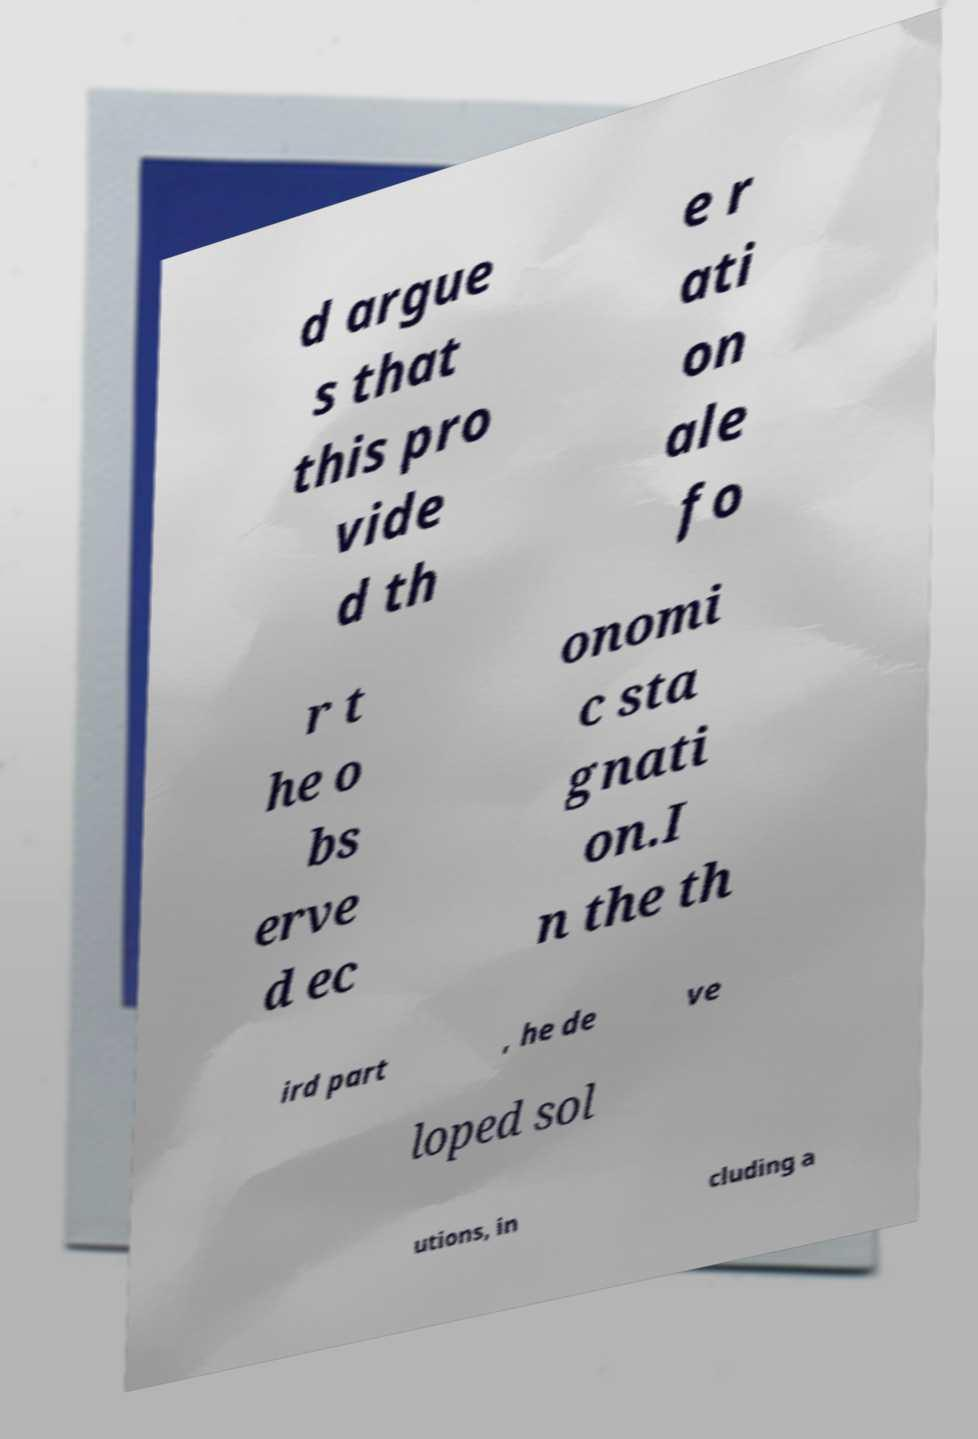I need the written content from this picture converted into text. Can you do that? d argue s that this pro vide d th e r ati on ale fo r t he o bs erve d ec onomi c sta gnati on.I n the th ird part , he de ve loped sol utions, in cluding a 